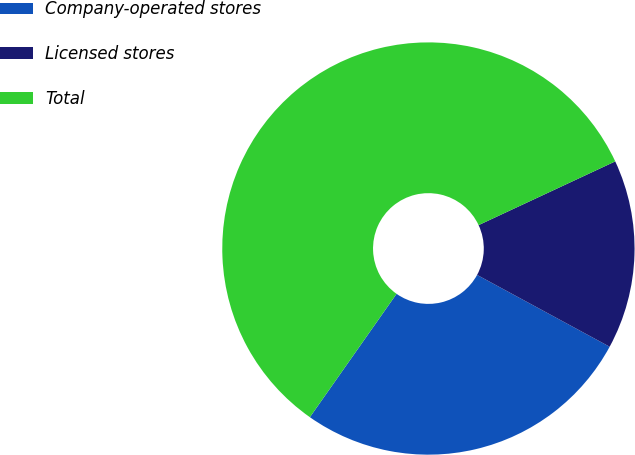<chart> <loc_0><loc_0><loc_500><loc_500><pie_chart><fcel>Company-operated stores<fcel>Licensed stores<fcel>Total<nl><fcel>26.85%<fcel>14.85%<fcel>58.31%<nl></chart> 